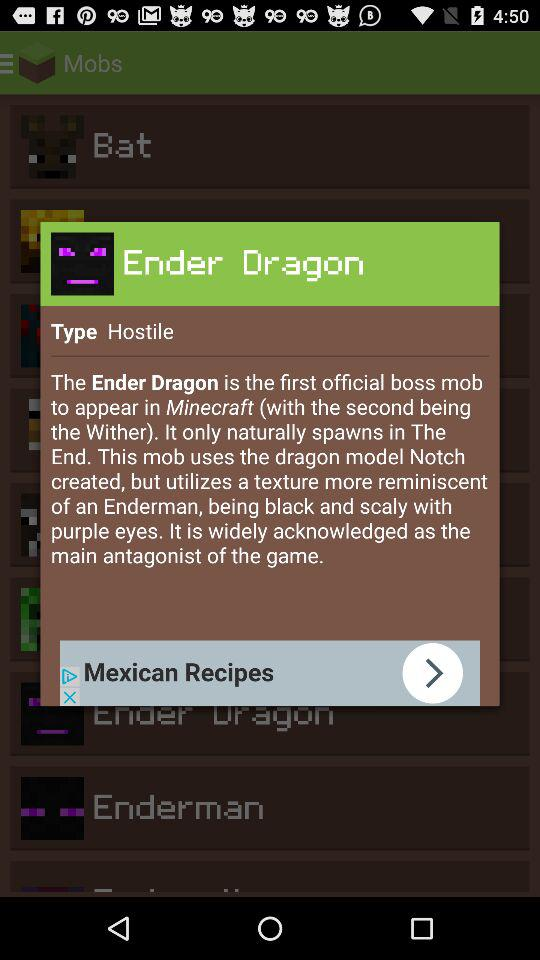What is the game name? The game name is "Block of Diamond". 